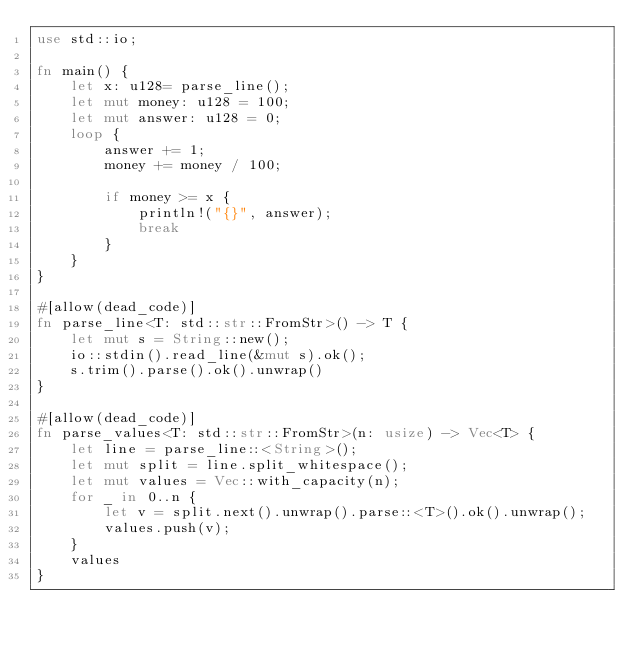Convert code to text. <code><loc_0><loc_0><loc_500><loc_500><_Rust_>use std::io;

fn main() {
    let x: u128= parse_line();
    let mut money: u128 = 100;
    let mut answer: u128 = 0;
    loop {
        answer += 1;
        money += money / 100;

        if money >= x {
            println!("{}", answer);
            break
        }
    }
}

#[allow(dead_code)]
fn parse_line<T: std::str::FromStr>() -> T {
    let mut s = String::new();
    io::stdin().read_line(&mut s).ok();
    s.trim().parse().ok().unwrap()
}

#[allow(dead_code)]
fn parse_values<T: std::str::FromStr>(n: usize) -> Vec<T> {
    let line = parse_line::<String>();
    let mut split = line.split_whitespace();
    let mut values = Vec::with_capacity(n);
    for _ in 0..n {
        let v = split.next().unwrap().parse::<T>().ok().unwrap();
        values.push(v);
    }
    values
}


</code> 